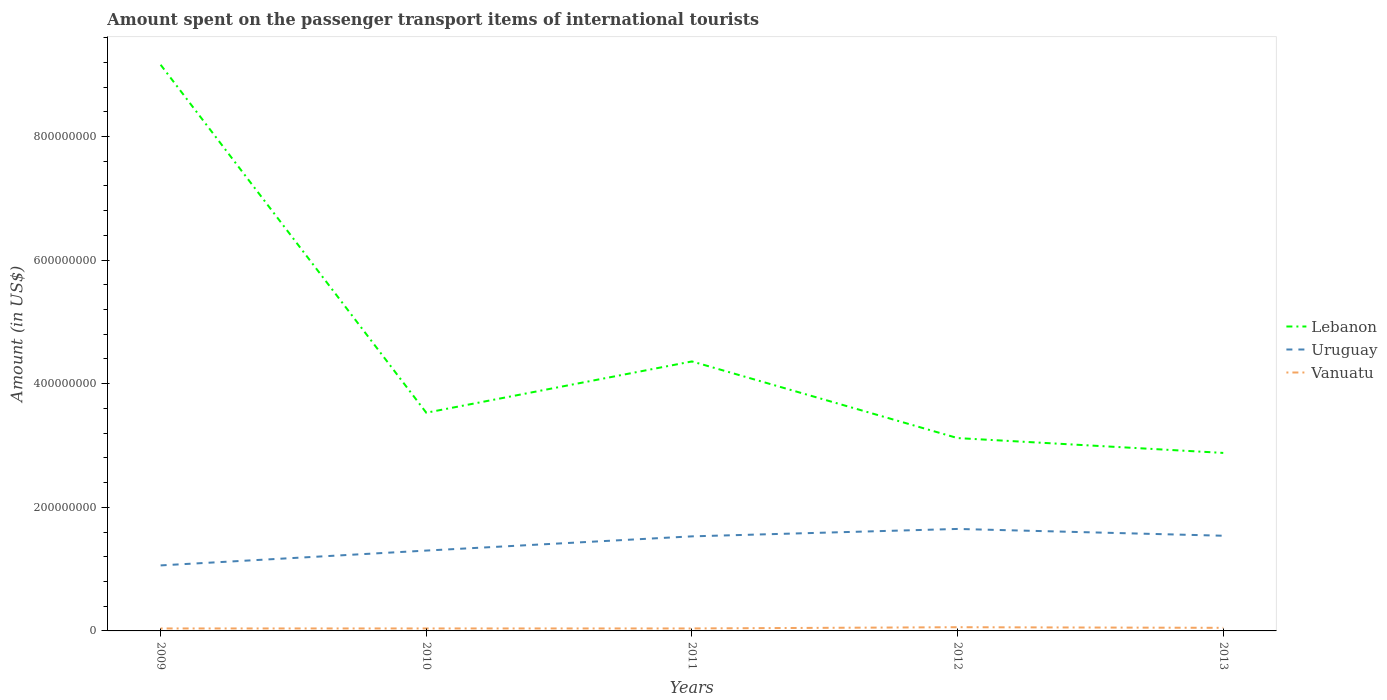How many different coloured lines are there?
Give a very brief answer. 3. Is the number of lines equal to the number of legend labels?
Provide a short and direct response. Yes. What is the total amount spent on the passenger transport items of international tourists in Vanuatu in the graph?
Give a very brief answer. -1.00e+06. What is the difference between the highest and the second highest amount spent on the passenger transport items of international tourists in Uruguay?
Your answer should be compact. 5.90e+07. What is the difference between the highest and the lowest amount spent on the passenger transport items of international tourists in Lebanon?
Offer a very short reply. 1. How many lines are there?
Offer a very short reply. 3. How many years are there in the graph?
Your answer should be compact. 5. Where does the legend appear in the graph?
Your answer should be compact. Center right. How many legend labels are there?
Keep it short and to the point. 3. What is the title of the graph?
Offer a terse response. Amount spent on the passenger transport items of international tourists. Does "Panama" appear as one of the legend labels in the graph?
Give a very brief answer. No. What is the label or title of the X-axis?
Provide a succinct answer. Years. What is the label or title of the Y-axis?
Your answer should be very brief. Amount (in US$). What is the Amount (in US$) in Lebanon in 2009?
Offer a very short reply. 9.16e+08. What is the Amount (in US$) in Uruguay in 2009?
Your response must be concise. 1.06e+08. What is the Amount (in US$) of Vanuatu in 2009?
Give a very brief answer. 4.00e+06. What is the Amount (in US$) in Lebanon in 2010?
Provide a short and direct response. 3.53e+08. What is the Amount (in US$) of Uruguay in 2010?
Keep it short and to the point. 1.30e+08. What is the Amount (in US$) of Lebanon in 2011?
Offer a terse response. 4.36e+08. What is the Amount (in US$) in Uruguay in 2011?
Offer a very short reply. 1.53e+08. What is the Amount (in US$) in Lebanon in 2012?
Keep it short and to the point. 3.12e+08. What is the Amount (in US$) of Uruguay in 2012?
Your response must be concise. 1.65e+08. What is the Amount (in US$) of Lebanon in 2013?
Your answer should be compact. 2.88e+08. What is the Amount (in US$) of Uruguay in 2013?
Your answer should be very brief. 1.54e+08. Across all years, what is the maximum Amount (in US$) of Lebanon?
Provide a short and direct response. 9.16e+08. Across all years, what is the maximum Amount (in US$) in Uruguay?
Provide a succinct answer. 1.65e+08. Across all years, what is the maximum Amount (in US$) in Vanuatu?
Make the answer very short. 6.00e+06. Across all years, what is the minimum Amount (in US$) of Lebanon?
Give a very brief answer. 2.88e+08. Across all years, what is the minimum Amount (in US$) in Uruguay?
Ensure brevity in your answer.  1.06e+08. What is the total Amount (in US$) of Lebanon in the graph?
Your response must be concise. 2.30e+09. What is the total Amount (in US$) in Uruguay in the graph?
Keep it short and to the point. 7.08e+08. What is the total Amount (in US$) of Vanuatu in the graph?
Ensure brevity in your answer.  2.30e+07. What is the difference between the Amount (in US$) in Lebanon in 2009 and that in 2010?
Make the answer very short. 5.63e+08. What is the difference between the Amount (in US$) in Uruguay in 2009 and that in 2010?
Provide a short and direct response. -2.40e+07. What is the difference between the Amount (in US$) in Vanuatu in 2009 and that in 2010?
Give a very brief answer. 0. What is the difference between the Amount (in US$) in Lebanon in 2009 and that in 2011?
Provide a short and direct response. 4.80e+08. What is the difference between the Amount (in US$) in Uruguay in 2009 and that in 2011?
Offer a terse response. -4.70e+07. What is the difference between the Amount (in US$) in Vanuatu in 2009 and that in 2011?
Your answer should be compact. 0. What is the difference between the Amount (in US$) of Lebanon in 2009 and that in 2012?
Ensure brevity in your answer.  6.04e+08. What is the difference between the Amount (in US$) of Uruguay in 2009 and that in 2012?
Your answer should be very brief. -5.90e+07. What is the difference between the Amount (in US$) in Lebanon in 2009 and that in 2013?
Provide a succinct answer. 6.28e+08. What is the difference between the Amount (in US$) in Uruguay in 2009 and that in 2013?
Offer a terse response. -4.80e+07. What is the difference between the Amount (in US$) of Lebanon in 2010 and that in 2011?
Give a very brief answer. -8.30e+07. What is the difference between the Amount (in US$) in Uruguay in 2010 and that in 2011?
Ensure brevity in your answer.  -2.30e+07. What is the difference between the Amount (in US$) in Vanuatu in 2010 and that in 2011?
Keep it short and to the point. 0. What is the difference between the Amount (in US$) of Lebanon in 2010 and that in 2012?
Make the answer very short. 4.10e+07. What is the difference between the Amount (in US$) of Uruguay in 2010 and that in 2012?
Make the answer very short. -3.50e+07. What is the difference between the Amount (in US$) in Vanuatu in 2010 and that in 2012?
Make the answer very short. -2.00e+06. What is the difference between the Amount (in US$) in Lebanon in 2010 and that in 2013?
Keep it short and to the point. 6.50e+07. What is the difference between the Amount (in US$) of Uruguay in 2010 and that in 2013?
Give a very brief answer. -2.40e+07. What is the difference between the Amount (in US$) of Vanuatu in 2010 and that in 2013?
Offer a terse response. -1.00e+06. What is the difference between the Amount (in US$) of Lebanon in 2011 and that in 2012?
Make the answer very short. 1.24e+08. What is the difference between the Amount (in US$) in Uruguay in 2011 and that in 2012?
Offer a very short reply. -1.20e+07. What is the difference between the Amount (in US$) in Lebanon in 2011 and that in 2013?
Provide a short and direct response. 1.48e+08. What is the difference between the Amount (in US$) of Uruguay in 2011 and that in 2013?
Offer a terse response. -1.00e+06. What is the difference between the Amount (in US$) in Lebanon in 2012 and that in 2013?
Ensure brevity in your answer.  2.40e+07. What is the difference between the Amount (in US$) in Uruguay in 2012 and that in 2013?
Make the answer very short. 1.10e+07. What is the difference between the Amount (in US$) of Vanuatu in 2012 and that in 2013?
Offer a very short reply. 1.00e+06. What is the difference between the Amount (in US$) in Lebanon in 2009 and the Amount (in US$) in Uruguay in 2010?
Give a very brief answer. 7.86e+08. What is the difference between the Amount (in US$) in Lebanon in 2009 and the Amount (in US$) in Vanuatu in 2010?
Your response must be concise. 9.12e+08. What is the difference between the Amount (in US$) of Uruguay in 2009 and the Amount (in US$) of Vanuatu in 2010?
Keep it short and to the point. 1.02e+08. What is the difference between the Amount (in US$) in Lebanon in 2009 and the Amount (in US$) in Uruguay in 2011?
Ensure brevity in your answer.  7.63e+08. What is the difference between the Amount (in US$) of Lebanon in 2009 and the Amount (in US$) of Vanuatu in 2011?
Ensure brevity in your answer.  9.12e+08. What is the difference between the Amount (in US$) in Uruguay in 2009 and the Amount (in US$) in Vanuatu in 2011?
Your answer should be compact. 1.02e+08. What is the difference between the Amount (in US$) of Lebanon in 2009 and the Amount (in US$) of Uruguay in 2012?
Your answer should be very brief. 7.51e+08. What is the difference between the Amount (in US$) of Lebanon in 2009 and the Amount (in US$) of Vanuatu in 2012?
Offer a terse response. 9.10e+08. What is the difference between the Amount (in US$) of Uruguay in 2009 and the Amount (in US$) of Vanuatu in 2012?
Your answer should be compact. 1.00e+08. What is the difference between the Amount (in US$) in Lebanon in 2009 and the Amount (in US$) in Uruguay in 2013?
Your answer should be compact. 7.62e+08. What is the difference between the Amount (in US$) of Lebanon in 2009 and the Amount (in US$) of Vanuatu in 2013?
Keep it short and to the point. 9.11e+08. What is the difference between the Amount (in US$) of Uruguay in 2009 and the Amount (in US$) of Vanuatu in 2013?
Provide a succinct answer. 1.01e+08. What is the difference between the Amount (in US$) in Lebanon in 2010 and the Amount (in US$) in Vanuatu in 2011?
Offer a very short reply. 3.49e+08. What is the difference between the Amount (in US$) of Uruguay in 2010 and the Amount (in US$) of Vanuatu in 2011?
Offer a very short reply. 1.26e+08. What is the difference between the Amount (in US$) of Lebanon in 2010 and the Amount (in US$) of Uruguay in 2012?
Ensure brevity in your answer.  1.88e+08. What is the difference between the Amount (in US$) in Lebanon in 2010 and the Amount (in US$) in Vanuatu in 2012?
Keep it short and to the point. 3.47e+08. What is the difference between the Amount (in US$) in Uruguay in 2010 and the Amount (in US$) in Vanuatu in 2012?
Provide a short and direct response. 1.24e+08. What is the difference between the Amount (in US$) in Lebanon in 2010 and the Amount (in US$) in Uruguay in 2013?
Ensure brevity in your answer.  1.99e+08. What is the difference between the Amount (in US$) of Lebanon in 2010 and the Amount (in US$) of Vanuatu in 2013?
Give a very brief answer. 3.48e+08. What is the difference between the Amount (in US$) in Uruguay in 2010 and the Amount (in US$) in Vanuatu in 2013?
Your answer should be compact. 1.25e+08. What is the difference between the Amount (in US$) in Lebanon in 2011 and the Amount (in US$) in Uruguay in 2012?
Provide a succinct answer. 2.71e+08. What is the difference between the Amount (in US$) of Lebanon in 2011 and the Amount (in US$) of Vanuatu in 2012?
Ensure brevity in your answer.  4.30e+08. What is the difference between the Amount (in US$) of Uruguay in 2011 and the Amount (in US$) of Vanuatu in 2012?
Offer a terse response. 1.47e+08. What is the difference between the Amount (in US$) in Lebanon in 2011 and the Amount (in US$) in Uruguay in 2013?
Offer a terse response. 2.82e+08. What is the difference between the Amount (in US$) of Lebanon in 2011 and the Amount (in US$) of Vanuatu in 2013?
Keep it short and to the point. 4.31e+08. What is the difference between the Amount (in US$) of Uruguay in 2011 and the Amount (in US$) of Vanuatu in 2013?
Provide a short and direct response. 1.48e+08. What is the difference between the Amount (in US$) in Lebanon in 2012 and the Amount (in US$) in Uruguay in 2013?
Provide a succinct answer. 1.58e+08. What is the difference between the Amount (in US$) of Lebanon in 2012 and the Amount (in US$) of Vanuatu in 2013?
Provide a short and direct response. 3.07e+08. What is the difference between the Amount (in US$) in Uruguay in 2012 and the Amount (in US$) in Vanuatu in 2013?
Ensure brevity in your answer.  1.60e+08. What is the average Amount (in US$) in Lebanon per year?
Make the answer very short. 4.61e+08. What is the average Amount (in US$) of Uruguay per year?
Your answer should be very brief. 1.42e+08. What is the average Amount (in US$) in Vanuatu per year?
Give a very brief answer. 4.60e+06. In the year 2009, what is the difference between the Amount (in US$) of Lebanon and Amount (in US$) of Uruguay?
Your answer should be very brief. 8.10e+08. In the year 2009, what is the difference between the Amount (in US$) of Lebanon and Amount (in US$) of Vanuatu?
Ensure brevity in your answer.  9.12e+08. In the year 2009, what is the difference between the Amount (in US$) of Uruguay and Amount (in US$) of Vanuatu?
Ensure brevity in your answer.  1.02e+08. In the year 2010, what is the difference between the Amount (in US$) of Lebanon and Amount (in US$) of Uruguay?
Offer a terse response. 2.23e+08. In the year 2010, what is the difference between the Amount (in US$) in Lebanon and Amount (in US$) in Vanuatu?
Offer a very short reply. 3.49e+08. In the year 2010, what is the difference between the Amount (in US$) of Uruguay and Amount (in US$) of Vanuatu?
Ensure brevity in your answer.  1.26e+08. In the year 2011, what is the difference between the Amount (in US$) in Lebanon and Amount (in US$) in Uruguay?
Your answer should be compact. 2.83e+08. In the year 2011, what is the difference between the Amount (in US$) in Lebanon and Amount (in US$) in Vanuatu?
Your response must be concise. 4.32e+08. In the year 2011, what is the difference between the Amount (in US$) of Uruguay and Amount (in US$) of Vanuatu?
Provide a short and direct response. 1.49e+08. In the year 2012, what is the difference between the Amount (in US$) of Lebanon and Amount (in US$) of Uruguay?
Your response must be concise. 1.47e+08. In the year 2012, what is the difference between the Amount (in US$) of Lebanon and Amount (in US$) of Vanuatu?
Your response must be concise. 3.06e+08. In the year 2012, what is the difference between the Amount (in US$) in Uruguay and Amount (in US$) in Vanuatu?
Your answer should be compact. 1.59e+08. In the year 2013, what is the difference between the Amount (in US$) in Lebanon and Amount (in US$) in Uruguay?
Offer a very short reply. 1.34e+08. In the year 2013, what is the difference between the Amount (in US$) of Lebanon and Amount (in US$) of Vanuatu?
Make the answer very short. 2.83e+08. In the year 2013, what is the difference between the Amount (in US$) in Uruguay and Amount (in US$) in Vanuatu?
Make the answer very short. 1.49e+08. What is the ratio of the Amount (in US$) in Lebanon in 2009 to that in 2010?
Offer a very short reply. 2.59. What is the ratio of the Amount (in US$) of Uruguay in 2009 to that in 2010?
Your response must be concise. 0.82. What is the ratio of the Amount (in US$) in Lebanon in 2009 to that in 2011?
Provide a short and direct response. 2.1. What is the ratio of the Amount (in US$) in Uruguay in 2009 to that in 2011?
Your answer should be very brief. 0.69. What is the ratio of the Amount (in US$) in Lebanon in 2009 to that in 2012?
Offer a very short reply. 2.94. What is the ratio of the Amount (in US$) of Uruguay in 2009 to that in 2012?
Keep it short and to the point. 0.64. What is the ratio of the Amount (in US$) of Lebanon in 2009 to that in 2013?
Your answer should be compact. 3.18. What is the ratio of the Amount (in US$) of Uruguay in 2009 to that in 2013?
Make the answer very short. 0.69. What is the ratio of the Amount (in US$) in Lebanon in 2010 to that in 2011?
Provide a succinct answer. 0.81. What is the ratio of the Amount (in US$) of Uruguay in 2010 to that in 2011?
Offer a terse response. 0.85. What is the ratio of the Amount (in US$) in Vanuatu in 2010 to that in 2011?
Provide a short and direct response. 1. What is the ratio of the Amount (in US$) in Lebanon in 2010 to that in 2012?
Ensure brevity in your answer.  1.13. What is the ratio of the Amount (in US$) of Uruguay in 2010 to that in 2012?
Your answer should be compact. 0.79. What is the ratio of the Amount (in US$) in Lebanon in 2010 to that in 2013?
Provide a short and direct response. 1.23. What is the ratio of the Amount (in US$) in Uruguay in 2010 to that in 2013?
Keep it short and to the point. 0.84. What is the ratio of the Amount (in US$) of Vanuatu in 2010 to that in 2013?
Offer a terse response. 0.8. What is the ratio of the Amount (in US$) in Lebanon in 2011 to that in 2012?
Your answer should be very brief. 1.4. What is the ratio of the Amount (in US$) of Uruguay in 2011 to that in 2012?
Your response must be concise. 0.93. What is the ratio of the Amount (in US$) of Vanuatu in 2011 to that in 2012?
Your answer should be very brief. 0.67. What is the ratio of the Amount (in US$) of Lebanon in 2011 to that in 2013?
Provide a short and direct response. 1.51. What is the ratio of the Amount (in US$) in Vanuatu in 2011 to that in 2013?
Offer a very short reply. 0.8. What is the ratio of the Amount (in US$) of Lebanon in 2012 to that in 2013?
Your answer should be very brief. 1.08. What is the ratio of the Amount (in US$) of Uruguay in 2012 to that in 2013?
Keep it short and to the point. 1.07. What is the difference between the highest and the second highest Amount (in US$) of Lebanon?
Ensure brevity in your answer.  4.80e+08. What is the difference between the highest and the second highest Amount (in US$) of Uruguay?
Offer a very short reply. 1.10e+07. What is the difference between the highest and the second highest Amount (in US$) of Vanuatu?
Provide a succinct answer. 1.00e+06. What is the difference between the highest and the lowest Amount (in US$) in Lebanon?
Provide a succinct answer. 6.28e+08. What is the difference between the highest and the lowest Amount (in US$) in Uruguay?
Give a very brief answer. 5.90e+07. 